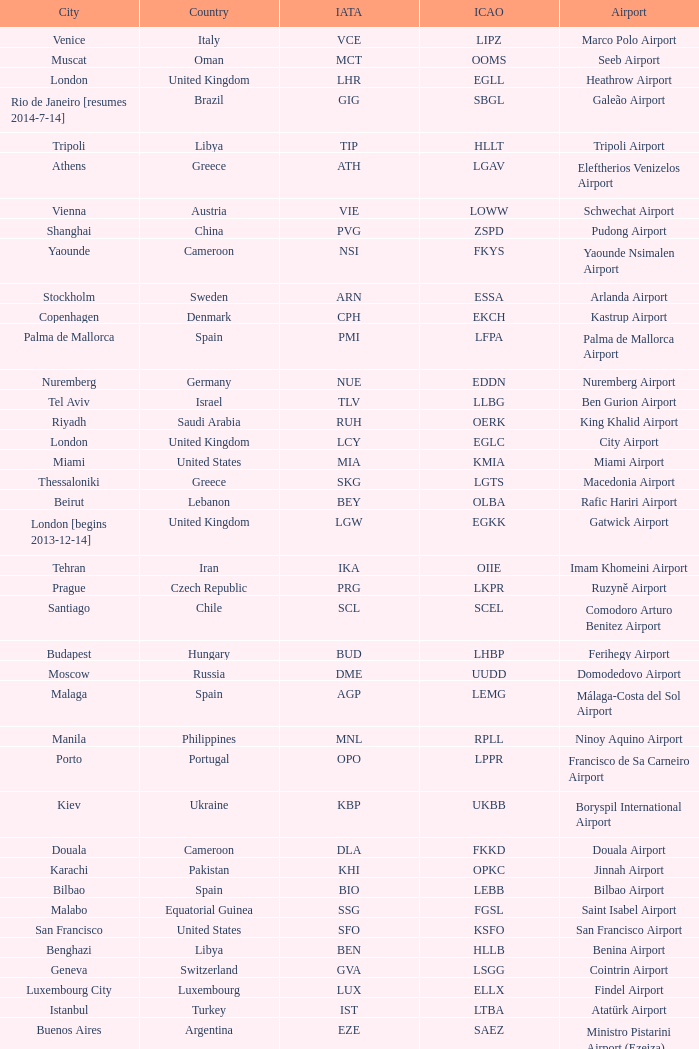What is the ICAO of Douala city? FKKD. 